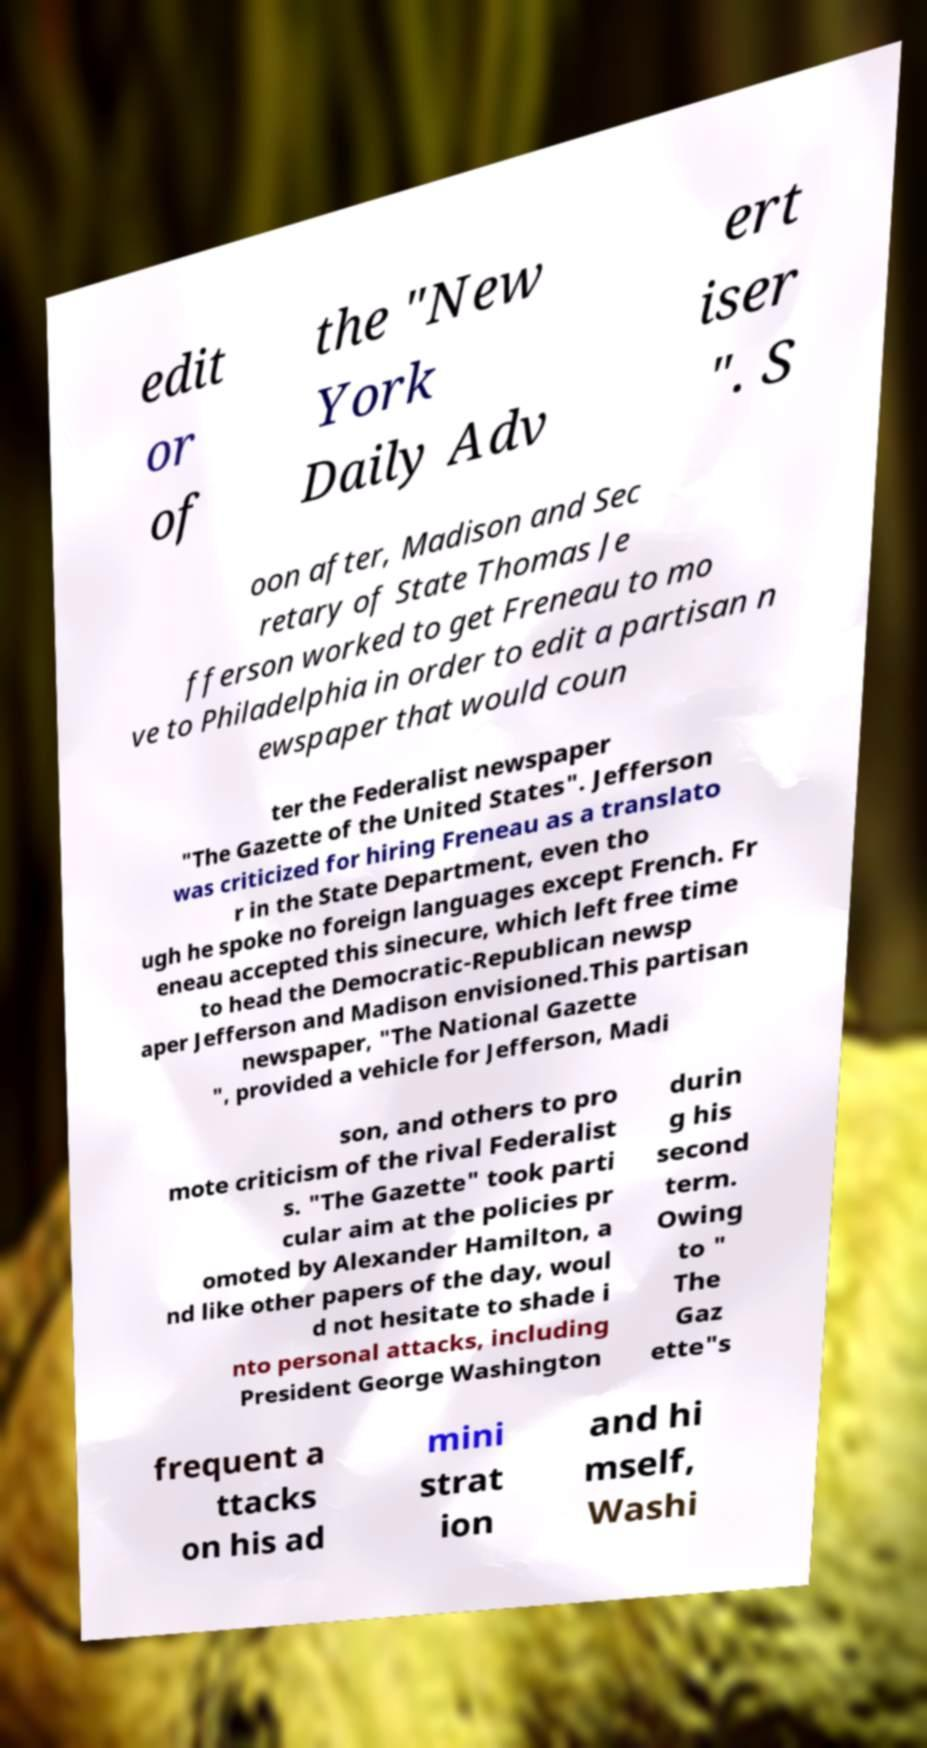Can you accurately transcribe the text from the provided image for me? edit or of the "New York Daily Adv ert iser ". S oon after, Madison and Sec retary of State Thomas Je fferson worked to get Freneau to mo ve to Philadelphia in order to edit a partisan n ewspaper that would coun ter the Federalist newspaper "The Gazette of the United States". Jefferson was criticized for hiring Freneau as a translato r in the State Department, even tho ugh he spoke no foreign languages except French. Fr eneau accepted this sinecure, which left free time to head the Democratic-Republican newsp aper Jefferson and Madison envisioned.This partisan newspaper, "The National Gazette ", provided a vehicle for Jefferson, Madi son, and others to pro mote criticism of the rival Federalist s. "The Gazette" took parti cular aim at the policies pr omoted by Alexander Hamilton, a nd like other papers of the day, woul d not hesitate to shade i nto personal attacks, including President George Washington durin g his second term. Owing to " The Gaz ette"s frequent a ttacks on his ad mini strat ion and hi mself, Washi 